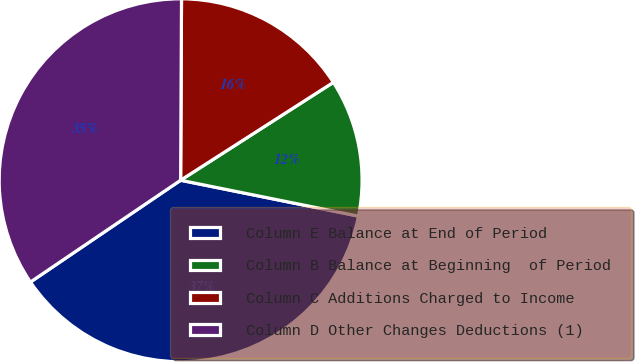Convert chart. <chart><loc_0><loc_0><loc_500><loc_500><pie_chart><fcel>Column E Balance at End of Period<fcel>Column B Balance at Beginning  of Period<fcel>Column C Additions Charged to Income<fcel>Column D Other Changes Deductions (1)<nl><fcel>37.35%<fcel>12.24%<fcel>15.85%<fcel>34.56%<nl></chart> 